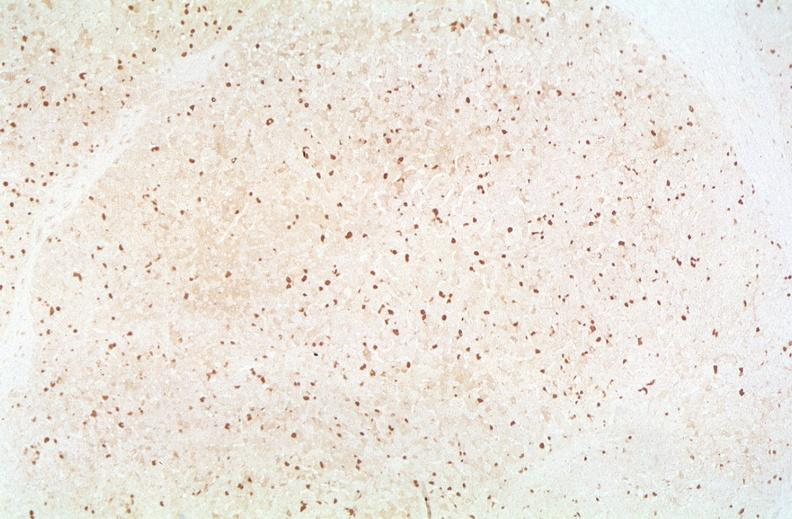s traumatic rupture present?
Answer the question using a single word or phrase. No 